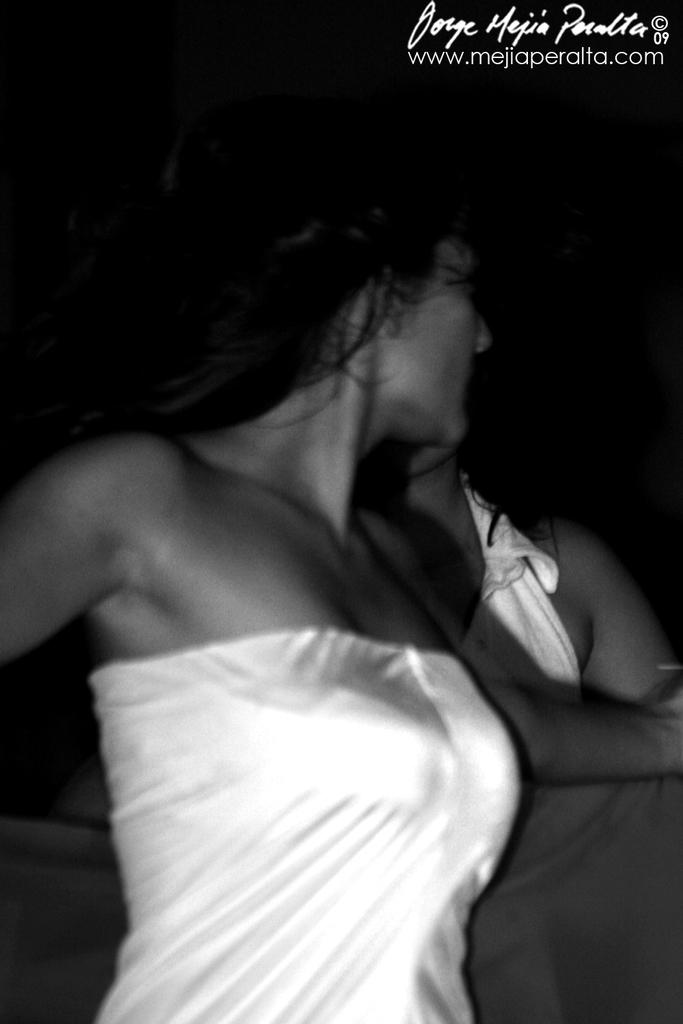Who is the main subject in the foreground of the image? There is a woman in the foreground of the image. What is the woman holding in the image? The woman is holding a bed sheet. Can you describe the person in the background of the image? There is another person in the background of the image. What type of school can be seen in the background of the image? There is no school visible in the image; it only features a woman holding a bed sheet and another person in the background. 